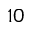Convert formula to latex. <formula><loc_0><loc_0><loc_500><loc_500>^ { 1 0 }</formula> 